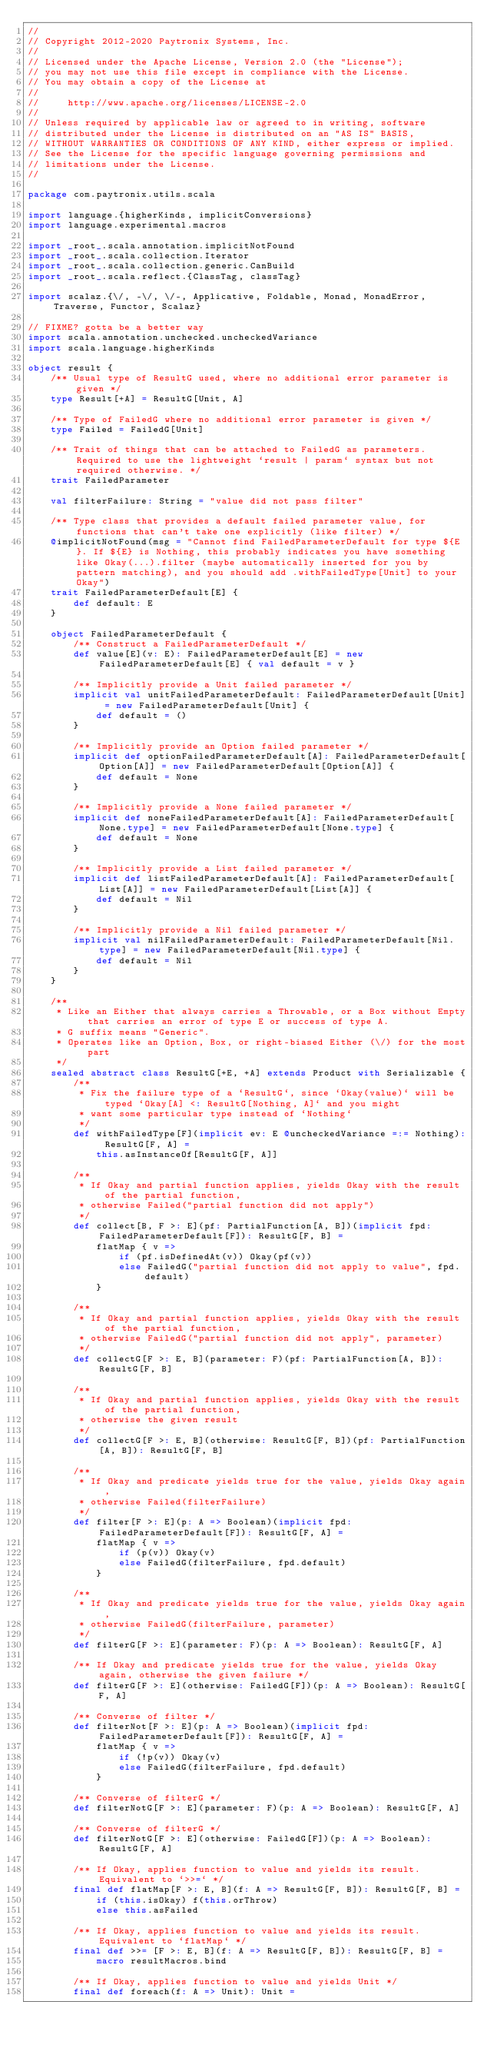<code> <loc_0><loc_0><loc_500><loc_500><_Scala_>//
// Copyright 2012-2020 Paytronix Systems, Inc.
//
// Licensed under the Apache License, Version 2.0 (the "License");
// you may not use this file except in compliance with the License.
// You may obtain a copy of the License at
//
//     http://www.apache.org/licenses/LICENSE-2.0
//
// Unless required by applicable law or agreed to in writing, software
// distributed under the License is distributed on an "AS IS" BASIS,
// WITHOUT WARRANTIES OR CONDITIONS OF ANY KIND, either express or implied.
// See the License for the specific language governing permissions and
// limitations under the License.
//

package com.paytronix.utils.scala

import language.{higherKinds, implicitConversions}
import language.experimental.macros

import _root_.scala.annotation.implicitNotFound
import _root_.scala.collection.Iterator
import _root_.scala.collection.generic.CanBuild
import _root_.scala.reflect.{ClassTag, classTag}

import scalaz.{\/, -\/, \/-, Applicative, Foldable, Monad, MonadError, Traverse, Functor, Scalaz}

// FIXME? gotta be a better way
import scala.annotation.unchecked.uncheckedVariance
import scala.language.higherKinds

object result {
    /** Usual type of ResultG used, where no additional error parameter is given */
    type Result[+A] = ResultG[Unit, A]

    /** Type of FailedG where no additional error parameter is given */
    type Failed = FailedG[Unit]

    /** Trait of things that can be attached to FailedG as parameters. Required to use the lightweight `result | param` syntax but not required otherwise. */
    trait FailedParameter

    val filterFailure: String = "value did not pass filter"

    /** Type class that provides a default failed parameter value, for functions that can't take one explicitly (like filter) */
    @implicitNotFound(msg = "Cannot find FailedParameterDefault for type ${E}. If ${E} is Nothing, this probably indicates you have something like Okay(...).filter (maybe automatically inserted for you by pattern matching), and you should add .withFailedType[Unit] to your Okay")
    trait FailedParameterDefault[E] {
        def default: E
    }

    object FailedParameterDefault {
        /** Construct a FailedParameterDefault */
        def value[E](v: E): FailedParameterDefault[E] = new FailedParameterDefault[E] { val default = v }

        /** Implicitly provide a Unit failed parameter */
        implicit val unitFailedParameterDefault: FailedParameterDefault[Unit] = new FailedParameterDefault[Unit] {
            def default = ()
        }

        /** Implicitly provide an Option failed parameter */
        implicit def optionFailedParameterDefault[A]: FailedParameterDefault[Option[A]] = new FailedParameterDefault[Option[A]] {
            def default = None
        }

        /** Implicitly provide a None failed parameter */
        implicit def noneFailedParameterDefault[A]: FailedParameterDefault[None.type] = new FailedParameterDefault[None.type] {
            def default = None
        }

        /** Implicitly provide a List failed parameter */
        implicit def listFailedParameterDefault[A]: FailedParameterDefault[List[A]] = new FailedParameterDefault[List[A]] {
            def default = Nil
        }

        /** Implicitly provide a Nil failed parameter */
        implicit val nilFailedParameterDefault: FailedParameterDefault[Nil.type] = new FailedParameterDefault[Nil.type] {
            def default = Nil
        }
    }

    /**
     * Like an Either that always carries a Throwable, or a Box without Empty that carries an error of type E or success of type A.
     * G suffix means "Generic".
     * Operates like an Option, Box, or right-biased Either (\/) for the most part
     */
    sealed abstract class ResultG[+E, +A] extends Product with Serializable {
        /**
         * Fix the failure type of a `ResultG`, since `Okay(value)` will be typed `Okay[A] <: ResultG[Nothing, A]` and you might
         * want some particular type instead of `Nothing`
         */
        def withFailedType[F](implicit ev: E @uncheckedVariance =:= Nothing): ResultG[F, A] =
            this.asInstanceOf[ResultG[F, A]]

        /**
         * If Okay and partial function applies, yields Okay with the result of the partial function,
         * otherwise Failed("partial function did not apply")
         */
        def collect[B, F >: E](pf: PartialFunction[A, B])(implicit fpd: FailedParameterDefault[F]): ResultG[F, B] =
            flatMap { v =>
                if (pf.isDefinedAt(v)) Okay(pf(v))
                else FailedG("partial function did not apply to value", fpd.default)
            }

        /**
         * If Okay and partial function applies, yields Okay with the result of the partial function,
         * otherwise FailedG("partial function did not apply", parameter)
         */
        def collectG[F >: E, B](parameter: F)(pf: PartialFunction[A, B]): ResultG[F, B]

        /**
         * If Okay and partial function applies, yields Okay with the result of the partial function,
         * otherwise the given result
         */
        def collectG[F >: E, B](otherwise: ResultG[F, B])(pf: PartialFunction[A, B]): ResultG[F, B]

        /**
         * If Okay and predicate yields true for the value, yields Okay again,
         * otherwise Failed(filterFailure)
         */
        def filter[F >: E](p: A => Boolean)(implicit fpd: FailedParameterDefault[F]): ResultG[F, A] =
            flatMap { v =>
                if (p(v)) Okay(v)
                else FailedG(filterFailure, fpd.default)
            }

        /**
         * If Okay and predicate yields true for the value, yields Okay again,
         * otherwise FailedG(filterFailure, parameter)
         */
        def filterG[F >: E](parameter: F)(p: A => Boolean): ResultG[F, A]

        /** If Okay and predicate yields true for the value, yields Okay again, otherwise the given failure */
        def filterG[F >: E](otherwise: FailedG[F])(p: A => Boolean): ResultG[F, A]

        /** Converse of filter */
        def filterNot[F >: E](p: A => Boolean)(implicit fpd: FailedParameterDefault[F]): ResultG[F, A] =
            flatMap { v =>
                if (!p(v)) Okay(v)
                else FailedG(filterFailure, fpd.default)
            }

        /** Converse of filterG */
        def filterNotG[F >: E](parameter: F)(p: A => Boolean): ResultG[F, A]

        /** Converse of filterG */
        def filterNotG[F >: E](otherwise: FailedG[F])(p: A => Boolean): ResultG[F, A]

        /** If Okay, applies function to value and yields its result. Equivalent to `>>=` */
        final def flatMap[F >: E, B](f: A => ResultG[F, B]): ResultG[F, B] =
            if (this.isOkay) f(this.orThrow)
            else this.asFailed

        /** If Okay, applies function to value and yields its result. Equivalent to `flatMap` */
        final def >>= [F >: E, B](f: A => ResultG[F, B]): ResultG[F, B] =
            macro resultMacros.bind

        /** If Okay, applies function to value and yields Unit */
        final def foreach(f: A => Unit): Unit =</code> 